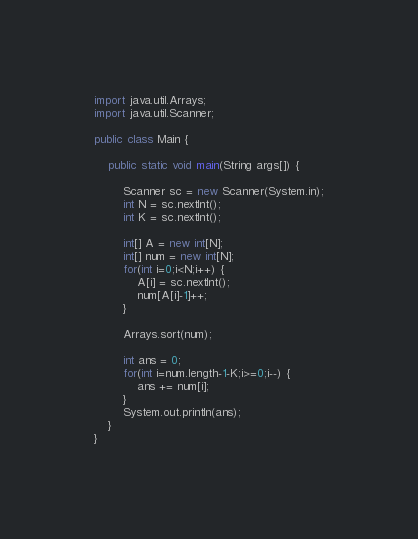Convert code to text. <code><loc_0><loc_0><loc_500><loc_500><_Java_>import java.util.Arrays;
import java.util.Scanner;

public class Main {

	public static void main(String args[]) {

		Scanner sc = new Scanner(System.in);
		int N = sc.nextInt();
		int K = sc.nextInt();

		int[] A = new int[N];
		int[] num = new int[N];
		for(int i=0;i<N;i++) {
			A[i] = sc.nextInt();
			num[A[i]-1]++;
		}

		Arrays.sort(num);

		int ans = 0;
		for(int i=num.length-1-K;i>=0;i--) {
			ans += num[i];
		}
		System.out.println(ans);
	}
}
</code> 